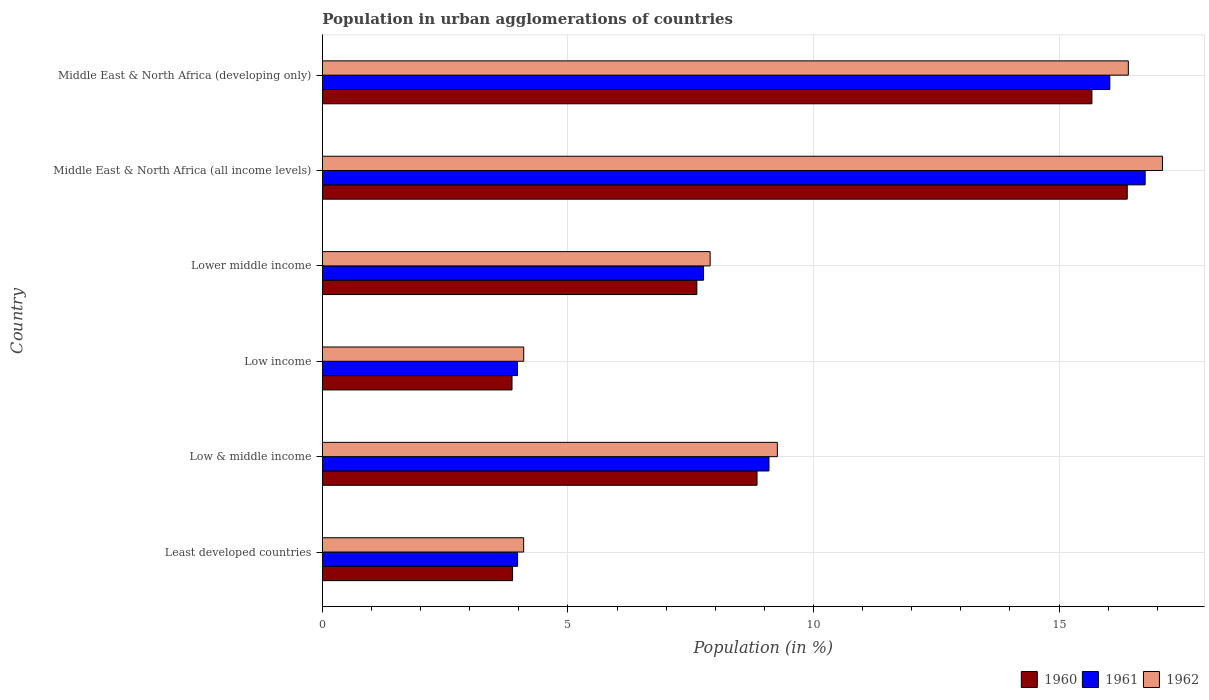How many different coloured bars are there?
Your response must be concise. 3. How many groups of bars are there?
Ensure brevity in your answer.  6. Are the number of bars per tick equal to the number of legend labels?
Your answer should be compact. Yes. Are the number of bars on each tick of the Y-axis equal?
Offer a terse response. Yes. What is the label of the 6th group of bars from the top?
Your answer should be compact. Least developed countries. In how many cases, is the number of bars for a given country not equal to the number of legend labels?
Make the answer very short. 0. What is the percentage of population in urban agglomerations in 1961 in Lower middle income?
Your answer should be very brief. 7.76. Across all countries, what is the maximum percentage of population in urban agglomerations in 1961?
Offer a very short reply. 16.75. Across all countries, what is the minimum percentage of population in urban agglomerations in 1960?
Your answer should be very brief. 3.86. In which country was the percentage of population in urban agglomerations in 1962 maximum?
Give a very brief answer. Middle East & North Africa (all income levels). What is the total percentage of population in urban agglomerations in 1962 in the graph?
Offer a terse response. 58.88. What is the difference between the percentage of population in urban agglomerations in 1962 in Least developed countries and that in Low & middle income?
Provide a short and direct response. -5.17. What is the difference between the percentage of population in urban agglomerations in 1960 in Middle East & North Africa (developing only) and the percentage of population in urban agglomerations in 1962 in Middle East & North Africa (all income levels)?
Make the answer very short. -1.44. What is the average percentage of population in urban agglomerations in 1962 per country?
Provide a short and direct response. 9.81. What is the difference between the percentage of population in urban agglomerations in 1961 and percentage of population in urban agglomerations in 1960 in Middle East & North Africa (all income levels)?
Give a very brief answer. 0.36. What is the ratio of the percentage of population in urban agglomerations in 1960 in Least developed countries to that in Lower middle income?
Your answer should be compact. 0.51. Is the percentage of population in urban agglomerations in 1960 in Least developed countries less than that in Lower middle income?
Ensure brevity in your answer.  Yes. What is the difference between the highest and the second highest percentage of population in urban agglomerations in 1961?
Ensure brevity in your answer.  0.72. What is the difference between the highest and the lowest percentage of population in urban agglomerations in 1962?
Keep it short and to the point. 13.01. In how many countries, is the percentage of population in urban agglomerations in 1962 greater than the average percentage of population in urban agglomerations in 1962 taken over all countries?
Ensure brevity in your answer.  2. Is the sum of the percentage of population in urban agglomerations in 1961 in Low & middle income and Lower middle income greater than the maximum percentage of population in urban agglomerations in 1960 across all countries?
Your answer should be very brief. Yes. What does the 2nd bar from the bottom in Lower middle income represents?
Ensure brevity in your answer.  1961. Is it the case that in every country, the sum of the percentage of population in urban agglomerations in 1961 and percentage of population in urban agglomerations in 1960 is greater than the percentage of population in urban agglomerations in 1962?
Your answer should be compact. Yes. Are all the bars in the graph horizontal?
Your response must be concise. Yes. Are the values on the major ticks of X-axis written in scientific E-notation?
Keep it short and to the point. No. Does the graph contain any zero values?
Your answer should be compact. No. Where does the legend appear in the graph?
Ensure brevity in your answer.  Bottom right. How are the legend labels stacked?
Offer a terse response. Horizontal. What is the title of the graph?
Give a very brief answer. Population in urban agglomerations of countries. Does "2007" appear as one of the legend labels in the graph?
Give a very brief answer. No. What is the label or title of the X-axis?
Provide a succinct answer. Population (in %). What is the Population (in %) of 1960 in Least developed countries?
Your answer should be very brief. 3.87. What is the Population (in %) of 1961 in Least developed countries?
Provide a short and direct response. 3.98. What is the Population (in %) of 1962 in Least developed countries?
Keep it short and to the point. 4.1. What is the Population (in %) of 1960 in Low & middle income?
Make the answer very short. 8.85. What is the Population (in %) in 1961 in Low & middle income?
Offer a terse response. 9.09. What is the Population (in %) in 1962 in Low & middle income?
Your response must be concise. 9.27. What is the Population (in %) in 1960 in Low income?
Your answer should be very brief. 3.86. What is the Population (in %) of 1961 in Low income?
Offer a very short reply. 3.97. What is the Population (in %) of 1962 in Low income?
Your answer should be very brief. 4.1. What is the Population (in %) of 1960 in Lower middle income?
Ensure brevity in your answer.  7.63. What is the Population (in %) of 1961 in Lower middle income?
Keep it short and to the point. 7.76. What is the Population (in %) of 1962 in Lower middle income?
Give a very brief answer. 7.9. What is the Population (in %) of 1960 in Middle East & North Africa (all income levels)?
Your response must be concise. 16.39. What is the Population (in %) of 1961 in Middle East & North Africa (all income levels)?
Your response must be concise. 16.75. What is the Population (in %) in 1962 in Middle East & North Africa (all income levels)?
Your answer should be very brief. 17.11. What is the Population (in %) of 1960 in Middle East & North Africa (developing only)?
Your answer should be compact. 15.67. What is the Population (in %) in 1961 in Middle East & North Africa (developing only)?
Keep it short and to the point. 16.03. What is the Population (in %) in 1962 in Middle East & North Africa (developing only)?
Offer a very short reply. 16.41. Across all countries, what is the maximum Population (in %) in 1960?
Provide a short and direct response. 16.39. Across all countries, what is the maximum Population (in %) of 1961?
Offer a terse response. 16.75. Across all countries, what is the maximum Population (in %) in 1962?
Offer a very short reply. 17.11. Across all countries, what is the minimum Population (in %) in 1960?
Give a very brief answer. 3.86. Across all countries, what is the minimum Population (in %) in 1961?
Ensure brevity in your answer.  3.97. Across all countries, what is the minimum Population (in %) of 1962?
Your response must be concise. 4.1. What is the total Population (in %) of 1960 in the graph?
Ensure brevity in your answer.  56.27. What is the total Population (in %) of 1961 in the graph?
Give a very brief answer. 57.59. What is the total Population (in %) in 1962 in the graph?
Your answer should be compact. 58.88. What is the difference between the Population (in %) of 1960 in Least developed countries and that in Low & middle income?
Your answer should be compact. -4.98. What is the difference between the Population (in %) in 1961 in Least developed countries and that in Low & middle income?
Ensure brevity in your answer.  -5.12. What is the difference between the Population (in %) in 1962 in Least developed countries and that in Low & middle income?
Provide a succinct answer. -5.17. What is the difference between the Population (in %) in 1960 in Least developed countries and that in Low income?
Your answer should be compact. 0.01. What is the difference between the Population (in %) in 1961 in Least developed countries and that in Low income?
Your response must be concise. 0. What is the difference between the Population (in %) of 1962 in Least developed countries and that in Low income?
Give a very brief answer. -0. What is the difference between the Population (in %) of 1960 in Least developed countries and that in Lower middle income?
Offer a terse response. -3.75. What is the difference between the Population (in %) of 1961 in Least developed countries and that in Lower middle income?
Provide a succinct answer. -3.79. What is the difference between the Population (in %) of 1962 in Least developed countries and that in Lower middle income?
Your answer should be very brief. -3.8. What is the difference between the Population (in %) of 1960 in Least developed countries and that in Middle East & North Africa (all income levels)?
Provide a short and direct response. -12.52. What is the difference between the Population (in %) of 1961 in Least developed countries and that in Middle East & North Africa (all income levels)?
Make the answer very short. -12.78. What is the difference between the Population (in %) in 1962 in Least developed countries and that in Middle East & North Africa (all income levels)?
Your answer should be very brief. -13.01. What is the difference between the Population (in %) of 1960 in Least developed countries and that in Middle East & North Africa (developing only)?
Offer a terse response. -11.8. What is the difference between the Population (in %) of 1961 in Least developed countries and that in Middle East & North Africa (developing only)?
Your response must be concise. -12.06. What is the difference between the Population (in %) of 1962 in Least developed countries and that in Middle East & North Africa (developing only)?
Provide a short and direct response. -12.31. What is the difference between the Population (in %) in 1960 in Low & middle income and that in Low income?
Keep it short and to the point. 4.99. What is the difference between the Population (in %) in 1961 in Low & middle income and that in Low income?
Your answer should be compact. 5.12. What is the difference between the Population (in %) of 1962 in Low & middle income and that in Low income?
Give a very brief answer. 5.16. What is the difference between the Population (in %) of 1960 in Low & middle income and that in Lower middle income?
Your answer should be very brief. 1.23. What is the difference between the Population (in %) of 1961 in Low & middle income and that in Lower middle income?
Ensure brevity in your answer.  1.33. What is the difference between the Population (in %) of 1962 in Low & middle income and that in Lower middle income?
Give a very brief answer. 1.37. What is the difference between the Population (in %) in 1960 in Low & middle income and that in Middle East & North Africa (all income levels)?
Your response must be concise. -7.54. What is the difference between the Population (in %) of 1961 in Low & middle income and that in Middle East & North Africa (all income levels)?
Offer a very short reply. -7.66. What is the difference between the Population (in %) of 1962 in Low & middle income and that in Middle East & North Africa (all income levels)?
Provide a short and direct response. -7.84. What is the difference between the Population (in %) in 1960 in Low & middle income and that in Middle East & North Africa (developing only)?
Make the answer very short. -6.82. What is the difference between the Population (in %) of 1961 in Low & middle income and that in Middle East & North Africa (developing only)?
Provide a succinct answer. -6.94. What is the difference between the Population (in %) of 1962 in Low & middle income and that in Middle East & North Africa (developing only)?
Make the answer very short. -7.15. What is the difference between the Population (in %) in 1960 in Low income and that in Lower middle income?
Your answer should be compact. -3.76. What is the difference between the Population (in %) of 1961 in Low income and that in Lower middle income?
Your answer should be very brief. -3.79. What is the difference between the Population (in %) of 1962 in Low income and that in Lower middle income?
Offer a very short reply. -3.8. What is the difference between the Population (in %) of 1960 in Low income and that in Middle East & North Africa (all income levels)?
Your response must be concise. -12.53. What is the difference between the Population (in %) of 1961 in Low income and that in Middle East & North Africa (all income levels)?
Provide a succinct answer. -12.78. What is the difference between the Population (in %) of 1962 in Low income and that in Middle East & North Africa (all income levels)?
Provide a short and direct response. -13.01. What is the difference between the Population (in %) in 1960 in Low income and that in Middle East & North Africa (developing only)?
Your response must be concise. -11.81. What is the difference between the Population (in %) in 1961 in Low income and that in Middle East & North Africa (developing only)?
Keep it short and to the point. -12.06. What is the difference between the Population (in %) of 1962 in Low income and that in Middle East & North Africa (developing only)?
Provide a succinct answer. -12.31. What is the difference between the Population (in %) in 1960 in Lower middle income and that in Middle East & North Africa (all income levels)?
Make the answer very short. -8.76. What is the difference between the Population (in %) in 1961 in Lower middle income and that in Middle East & North Africa (all income levels)?
Ensure brevity in your answer.  -8.99. What is the difference between the Population (in %) of 1962 in Lower middle income and that in Middle East & North Africa (all income levels)?
Provide a short and direct response. -9.21. What is the difference between the Population (in %) of 1960 in Lower middle income and that in Middle East & North Africa (developing only)?
Provide a short and direct response. -8.04. What is the difference between the Population (in %) in 1961 in Lower middle income and that in Middle East & North Africa (developing only)?
Keep it short and to the point. -8.27. What is the difference between the Population (in %) in 1962 in Lower middle income and that in Middle East & North Africa (developing only)?
Offer a terse response. -8.51. What is the difference between the Population (in %) in 1960 in Middle East & North Africa (all income levels) and that in Middle East & North Africa (developing only)?
Provide a succinct answer. 0.72. What is the difference between the Population (in %) of 1961 in Middle East & North Africa (all income levels) and that in Middle East & North Africa (developing only)?
Offer a terse response. 0.72. What is the difference between the Population (in %) in 1962 in Middle East & North Africa (all income levels) and that in Middle East & North Africa (developing only)?
Give a very brief answer. 0.7. What is the difference between the Population (in %) in 1960 in Least developed countries and the Population (in %) in 1961 in Low & middle income?
Provide a succinct answer. -5.22. What is the difference between the Population (in %) of 1960 in Least developed countries and the Population (in %) of 1962 in Low & middle income?
Provide a short and direct response. -5.39. What is the difference between the Population (in %) in 1961 in Least developed countries and the Population (in %) in 1962 in Low & middle income?
Provide a short and direct response. -5.29. What is the difference between the Population (in %) in 1960 in Least developed countries and the Population (in %) in 1961 in Low income?
Keep it short and to the point. -0.1. What is the difference between the Population (in %) of 1960 in Least developed countries and the Population (in %) of 1962 in Low income?
Give a very brief answer. -0.23. What is the difference between the Population (in %) in 1961 in Least developed countries and the Population (in %) in 1962 in Low income?
Provide a short and direct response. -0.12. What is the difference between the Population (in %) of 1960 in Least developed countries and the Population (in %) of 1961 in Lower middle income?
Your answer should be compact. -3.89. What is the difference between the Population (in %) in 1960 in Least developed countries and the Population (in %) in 1962 in Lower middle income?
Keep it short and to the point. -4.02. What is the difference between the Population (in %) in 1961 in Least developed countries and the Population (in %) in 1962 in Lower middle income?
Make the answer very short. -3.92. What is the difference between the Population (in %) in 1960 in Least developed countries and the Population (in %) in 1961 in Middle East & North Africa (all income levels)?
Keep it short and to the point. -12.88. What is the difference between the Population (in %) of 1960 in Least developed countries and the Population (in %) of 1962 in Middle East & North Africa (all income levels)?
Your response must be concise. -13.23. What is the difference between the Population (in %) of 1961 in Least developed countries and the Population (in %) of 1962 in Middle East & North Africa (all income levels)?
Offer a very short reply. -13.13. What is the difference between the Population (in %) of 1960 in Least developed countries and the Population (in %) of 1961 in Middle East & North Africa (developing only)?
Provide a short and direct response. -12.16. What is the difference between the Population (in %) in 1960 in Least developed countries and the Population (in %) in 1962 in Middle East & North Africa (developing only)?
Your response must be concise. -12.54. What is the difference between the Population (in %) of 1961 in Least developed countries and the Population (in %) of 1962 in Middle East & North Africa (developing only)?
Keep it short and to the point. -12.44. What is the difference between the Population (in %) in 1960 in Low & middle income and the Population (in %) in 1961 in Low income?
Keep it short and to the point. 4.88. What is the difference between the Population (in %) in 1960 in Low & middle income and the Population (in %) in 1962 in Low income?
Your response must be concise. 4.75. What is the difference between the Population (in %) in 1961 in Low & middle income and the Population (in %) in 1962 in Low income?
Your answer should be very brief. 4.99. What is the difference between the Population (in %) of 1960 in Low & middle income and the Population (in %) of 1961 in Lower middle income?
Your answer should be compact. 1.09. What is the difference between the Population (in %) in 1960 in Low & middle income and the Population (in %) in 1962 in Lower middle income?
Provide a succinct answer. 0.95. What is the difference between the Population (in %) in 1961 in Low & middle income and the Population (in %) in 1962 in Lower middle income?
Your answer should be very brief. 1.2. What is the difference between the Population (in %) in 1960 in Low & middle income and the Population (in %) in 1961 in Middle East & North Africa (all income levels)?
Your answer should be compact. -7.9. What is the difference between the Population (in %) in 1960 in Low & middle income and the Population (in %) in 1962 in Middle East & North Africa (all income levels)?
Provide a short and direct response. -8.26. What is the difference between the Population (in %) in 1961 in Low & middle income and the Population (in %) in 1962 in Middle East & North Africa (all income levels)?
Your answer should be very brief. -8.01. What is the difference between the Population (in %) in 1960 in Low & middle income and the Population (in %) in 1961 in Middle East & North Africa (developing only)?
Your answer should be compact. -7.18. What is the difference between the Population (in %) in 1960 in Low & middle income and the Population (in %) in 1962 in Middle East & North Africa (developing only)?
Your answer should be compact. -7.56. What is the difference between the Population (in %) of 1961 in Low & middle income and the Population (in %) of 1962 in Middle East & North Africa (developing only)?
Make the answer very short. -7.32. What is the difference between the Population (in %) of 1960 in Low income and the Population (in %) of 1961 in Lower middle income?
Make the answer very short. -3.9. What is the difference between the Population (in %) of 1960 in Low income and the Population (in %) of 1962 in Lower middle income?
Your answer should be compact. -4.03. What is the difference between the Population (in %) in 1961 in Low income and the Population (in %) in 1962 in Lower middle income?
Provide a succinct answer. -3.92. What is the difference between the Population (in %) in 1960 in Low income and the Population (in %) in 1961 in Middle East & North Africa (all income levels)?
Give a very brief answer. -12.89. What is the difference between the Population (in %) in 1960 in Low income and the Population (in %) in 1962 in Middle East & North Africa (all income levels)?
Offer a very short reply. -13.24. What is the difference between the Population (in %) in 1961 in Low income and the Population (in %) in 1962 in Middle East & North Africa (all income levels)?
Provide a succinct answer. -13.13. What is the difference between the Population (in %) of 1960 in Low income and the Population (in %) of 1961 in Middle East & North Africa (developing only)?
Offer a very short reply. -12.17. What is the difference between the Population (in %) in 1960 in Low income and the Population (in %) in 1962 in Middle East & North Africa (developing only)?
Provide a short and direct response. -12.55. What is the difference between the Population (in %) in 1961 in Low income and the Population (in %) in 1962 in Middle East & North Africa (developing only)?
Give a very brief answer. -12.44. What is the difference between the Population (in %) in 1960 in Lower middle income and the Population (in %) in 1961 in Middle East & North Africa (all income levels)?
Give a very brief answer. -9.13. What is the difference between the Population (in %) of 1960 in Lower middle income and the Population (in %) of 1962 in Middle East & North Africa (all income levels)?
Keep it short and to the point. -9.48. What is the difference between the Population (in %) in 1961 in Lower middle income and the Population (in %) in 1962 in Middle East & North Africa (all income levels)?
Provide a succinct answer. -9.35. What is the difference between the Population (in %) in 1960 in Lower middle income and the Population (in %) in 1961 in Middle East & North Africa (developing only)?
Your answer should be compact. -8.41. What is the difference between the Population (in %) of 1960 in Lower middle income and the Population (in %) of 1962 in Middle East & North Africa (developing only)?
Give a very brief answer. -8.79. What is the difference between the Population (in %) in 1961 in Lower middle income and the Population (in %) in 1962 in Middle East & North Africa (developing only)?
Offer a very short reply. -8.65. What is the difference between the Population (in %) in 1960 in Middle East & North Africa (all income levels) and the Population (in %) in 1961 in Middle East & North Africa (developing only)?
Give a very brief answer. 0.35. What is the difference between the Population (in %) in 1960 in Middle East & North Africa (all income levels) and the Population (in %) in 1962 in Middle East & North Africa (developing only)?
Your answer should be compact. -0.02. What is the difference between the Population (in %) of 1961 in Middle East & North Africa (all income levels) and the Population (in %) of 1962 in Middle East & North Africa (developing only)?
Offer a terse response. 0.34. What is the average Population (in %) in 1960 per country?
Offer a terse response. 9.38. What is the average Population (in %) in 1961 per country?
Your response must be concise. 9.6. What is the average Population (in %) of 1962 per country?
Your answer should be compact. 9.81. What is the difference between the Population (in %) in 1960 and Population (in %) in 1961 in Least developed countries?
Offer a terse response. -0.1. What is the difference between the Population (in %) of 1960 and Population (in %) of 1962 in Least developed countries?
Your response must be concise. -0.23. What is the difference between the Population (in %) in 1961 and Population (in %) in 1962 in Least developed countries?
Your response must be concise. -0.12. What is the difference between the Population (in %) in 1960 and Population (in %) in 1961 in Low & middle income?
Keep it short and to the point. -0.24. What is the difference between the Population (in %) in 1960 and Population (in %) in 1962 in Low & middle income?
Your answer should be compact. -0.41. What is the difference between the Population (in %) in 1961 and Population (in %) in 1962 in Low & middle income?
Provide a succinct answer. -0.17. What is the difference between the Population (in %) in 1960 and Population (in %) in 1961 in Low income?
Make the answer very short. -0.11. What is the difference between the Population (in %) in 1960 and Population (in %) in 1962 in Low income?
Provide a short and direct response. -0.24. What is the difference between the Population (in %) of 1961 and Population (in %) of 1962 in Low income?
Make the answer very short. -0.13. What is the difference between the Population (in %) in 1960 and Population (in %) in 1961 in Lower middle income?
Your answer should be compact. -0.14. What is the difference between the Population (in %) of 1960 and Population (in %) of 1962 in Lower middle income?
Ensure brevity in your answer.  -0.27. What is the difference between the Population (in %) of 1961 and Population (in %) of 1962 in Lower middle income?
Give a very brief answer. -0.13. What is the difference between the Population (in %) of 1960 and Population (in %) of 1961 in Middle East & North Africa (all income levels)?
Make the answer very short. -0.36. What is the difference between the Population (in %) in 1960 and Population (in %) in 1962 in Middle East & North Africa (all income levels)?
Keep it short and to the point. -0.72. What is the difference between the Population (in %) in 1961 and Population (in %) in 1962 in Middle East & North Africa (all income levels)?
Ensure brevity in your answer.  -0.35. What is the difference between the Population (in %) in 1960 and Population (in %) in 1961 in Middle East & North Africa (developing only)?
Your answer should be very brief. -0.36. What is the difference between the Population (in %) of 1960 and Population (in %) of 1962 in Middle East & North Africa (developing only)?
Your answer should be very brief. -0.74. What is the difference between the Population (in %) in 1961 and Population (in %) in 1962 in Middle East & North Africa (developing only)?
Ensure brevity in your answer.  -0.38. What is the ratio of the Population (in %) in 1960 in Least developed countries to that in Low & middle income?
Ensure brevity in your answer.  0.44. What is the ratio of the Population (in %) in 1961 in Least developed countries to that in Low & middle income?
Provide a succinct answer. 0.44. What is the ratio of the Population (in %) of 1962 in Least developed countries to that in Low & middle income?
Provide a short and direct response. 0.44. What is the ratio of the Population (in %) in 1960 in Least developed countries to that in Low income?
Offer a very short reply. 1. What is the ratio of the Population (in %) in 1962 in Least developed countries to that in Low income?
Offer a very short reply. 1. What is the ratio of the Population (in %) in 1960 in Least developed countries to that in Lower middle income?
Provide a short and direct response. 0.51. What is the ratio of the Population (in %) of 1961 in Least developed countries to that in Lower middle income?
Your answer should be very brief. 0.51. What is the ratio of the Population (in %) in 1962 in Least developed countries to that in Lower middle income?
Give a very brief answer. 0.52. What is the ratio of the Population (in %) in 1960 in Least developed countries to that in Middle East & North Africa (all income levels)?
Your response must be concise. 0.24. What is the ratio of the Population (in %) of 1961 in Least developed countries to that in Middle East & North Africa (all income levels)?
Keep it short and to the point. 0.24. What is the ratio of the Population (in %) of 1962 in Least developed countries to that in Middle East & North Africa (all income levels)?
Give a very brief answer. 0.24. What is the ratio of the Population (in %) of 1960 in Least developed countries to that in Middle East & North Africa (developing only)?
Offer a terse response. 0.25. What is the ratio of the Population (in %) in 1961 in Least developed countries to that in Middle East & North Africa (developing only)?
Keep it short and to the point. 0.25. What is the ratio of the Population (in %) of 1962 in Least developed countries to that in Middle East & North Africa (developing only)?
Make the answer very short. 0.25. What is the ratio of the Population (in %) of 1960 in Low & middle income to that in Low income?
Ensure brevity in your answer.  2.29. What is the ratio of the Population (in %) of 1961 in Low & middle income to that in Low income?
Keep it short and to the point. 2.29. What is the ratio of the Population (in %) in 1962 in Low & middle income to that in Low income?
Ensure brevity in your answer.  2.26. What is the ratio of the Population (in %) of 1960 in Low & middle income to that in Lower middle income?
Offer a terse response. 1.16. What is the ratio of the Population (in %) of 1961 in Low & middle income to that in Lower middle income?
Your response must be concise. 1.17. What is the ratio of the Population (in %) of 1962 in Low & middle income to that in Lower middle income?
Make the answer very short. 1.17. What is the ratio of the Population (in %) in 1960 in Low & middle income to that in Middle East & North Africa (all income levels)?
Your response must be concise. 0.54. What is the ratio of the Population (in %) of 1961 in Low & middle income to that in Middle East & North Africa (all income levels)?
Make the answer very short. 0.54. What is the ratio of the Population (in %) in 1962 in Low & middle income to that in Middle East & North Africa (all income levels)?
Give a very brief answer. 0.54. What is the ratio of the Population (in %) in 1960 in Low & middle income to that in Middle East & North Africa (developing only)?
Provide a succinct answer. 0.56. What is the ratio of the Population (in %) in 1961 in Low & middle income to that in Middle East & North Africa (developing only)?
Keep it short and to the point. 0.57. What is the ratio of the Population (in %) in 1962 in Low & middle income to that in Middle East & North Africa (developing only)?
Your answer should be compact. 0.56. What is the ratio of the Population (in %) of 1960 in Low income to that in Lower middle income?
Give a very brief answer. 0.51. What is the ratio of the Population (in %) of 1961 in Low income to that in Lower middle income?
Provide a short and direct response. 0.51. What is the ratio of the Population (in %) of 1962 in Low income to that in Lower middle income?
Your answer should be very brief. 0.52. What is the ratio of the Population (in %) of 1960 in Low income to that in Middle East & North Africa (all income levels)?
Ensure brevity in your answer.  0.24. What is the ratio of the Population (in %) of 1961 in Low income to that in Middle East & North Africa (all income levels)?
Give a very brief answer. 0.24. What is the ratio of the Population (in %) of 1962 in Low income to that in Middle East & North Africa (all income levels)?
Provide a succinct answer. 0.24. What is the ratio of the Population (in %) of 1960 in Low income to that in Middle East & North Africa (developing only)?
Offer a terse response. 0.25. What is the ratio of the Population (in %) of 1961 in Low income to that in Middle East & North Africa (developing only)?
Give a very brief answer. 0.25. What is the ratio of the Population (in %) of 1962 in Low income to that in Middle East & North Africa (developing only)?
Offer a very short reply. 0.25. What is the ratio of the Population (in %) of 1960 in Lower middle income to that in Middle East & North Africa (all income levels)?
Ensure brevity in your answer.  0.47. What is the ratio of the Population (in %) in 1961 in Lower middle income to that in Middle East & North Africa (all income levels)?
Your response must be concise. 0.46. What is the ratio of the Population (in %) of 1962 in Lower middle income to that in Middle East & North Africa (all income levels)?
Provide a succinct answer. 0.46. What is the ratio of the Population (in %) in 1960 in Lower middle income to that in Middle East & North Africa (developing only)?
Ensure brevity in your answer.  0.49. What is the ratio of the Population (in %) of 1961 in Lower middle income to that in Middle East & North Africa (developing only)?
Provide a short and direct response. 0.48. What is the ratio of the Population (in %) of 1962 in Lower middle income to that in Middle East & North Africa (developing only)?
Provide a short and direct response. 0.48. What is the ratio of the Population (in %) of 1960 in Middle East & North Africa (all income levels) to that in Middle East & North Africa (developing only)?
Your answer should be compact. 1.05. What is the ratio of the Population (in %) in 1961 in Middle East & North Africa (all income levels) to that in Middle East & North Africa (developing only)?
Provide a short and direct response. 1.04. What is the ratio of the Population (in %) in 1962 in Middle East & North Africa (all income levels) to that in Middle East & North Africa (developing only)?
Offer a very short reply. 1.04. What is the difference between the highest and the second highest Population (in %) of 1960?
Offer a very short reply. 0.72. What is the difference between the highest and the second highest Population (in %) in 1961?
Your answer should be compact. 0.72. What is the difference between the highest and the second highest Population (in %) in 1962?
Your response must be concise. 0.7. What is the difference between the highest and the lowest Population (in %) in 1960?
Provide a succinct answer. 12.53. What is the difference between the highest and the lowest Population (in %) in 1961?
Provide a short and direct response. 12.78. What is the difference between the highest and the lowest Population (in %) in 1962?
Your answer should be compact. 13.01. 